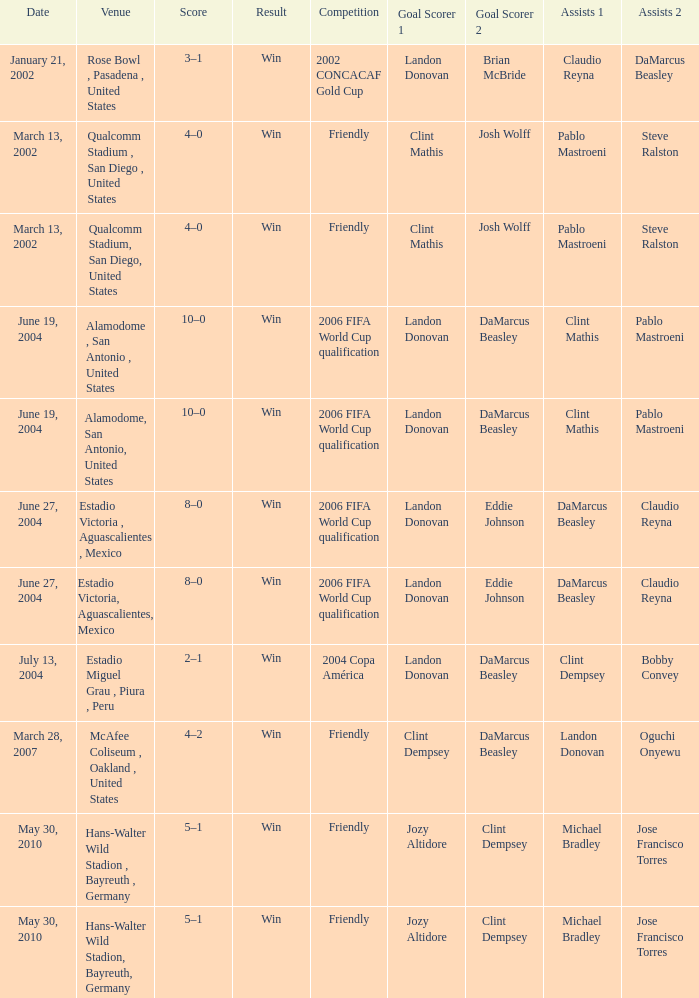What result has January 21, 2002 as the date? Win. Could you parse the entire table? {'header': ['Date', 'Venue', 'Score', 'Result', 'Competition', 'Goal Scorer 1', 'Goal Scorer 2', 'Assists 1', 'Assists 2'], 'rows': [['January 21, 2002', 'Rose Bowl , Pasadena , United States', '3–1', 'Win', '2002 CONCACAF Gold Cup', 'Landon Donovan', 'Brian McBride', 'Claudio Reyna', 'DaMarcus Beasley'], ['March 13, 2002', 'Qualcomm Stadium , San Diego , United States', '4–0', 'Win', 'Friendly', 'Clint Mathis', 'Josh Wolff', 'Pablo Mastroeni', 'Steve Ralston'], ['March 13, 2002', 'Qualcomm Stadium, San Diego, United States', '4–0', 'Win', 'Friendly', 'Clint Mathis', 'Josh Wolff', 'Pablo Mastroeni', 'Steve Ralston'], ['June 19, 2004', 'Alamodome , San Antonio , United States', '10–0', 'Win', '2006 FIFA World Cup qualification', 'Landon Donovan', 'DaMarcus Beasley', 'Clint Mathis', 'Pablo Mastroeni'], ['June 19, 2004', 'Alamodome, San Antonio, United States', '10–0', 'Win', '2006 FIFA World Cup qualification', 'Landon Donovan', 'DaMarcus Beasley', 'Clint Mathis', 'Pablo Mastroeni'], ['June 27, 2004', 'Estadio Victoria , Aguascalientes , Mexico', '8–0', 'Win', '2006 FIFA World Cup qualification', 'Landon Donovan', 'Eddie Johnson', 'DaMarcus Beasley', 'Claudio Reyna'], ['June 27, 2004', 'Estadio Victoria, Aguascalientes, Mexico', '8–0', 'Win', '2006 FIFA World Cup qualification', 'Landon Donovan', 'Eddie Johnson', 'DaMarcus Beasley', 'Claudio Reyna'], ['July 13, 2004', 'Estadio Miguel Grau , Piura , Peru', '2–1', 'Win', '2004 Copa América', 'Landon Donovan', 'DaMarcus Beasley', 'Clint Dempsey', 'Bobby Convey'], ['March 28, 2007', 'McAfee Coliseum , Oakland , United States', '4–2', 'Win', 'Friendly', 'Clint Dempsey', 'DaMarcus Beasley', 'Landon Donovan', 'Oguchi Onyewu'], ['May 30, 2010', 'Hans-Walter Wild Stadion , Bayreuth , Germany', '5–1', 'Win', 'Friendly', 'Jozy Altidore', 'Clint Dempsey', 'Michael Bradley', 'Jose Francisco Torres'], ['May 30, 2010', 'Hans-Walter Wild Stadion, Bayreuth, Germany', '5–1', 'Win', 'Friendly', 'Jozy Altidore', 'Clint Dempsey', 'Michael Bradley', 'Jose Francisco Torres']]} 